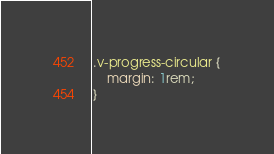Convert code to text. <code><loc_0><loc_0><loc_500><loc_500><_CSS_>.v-progress-circular {
    margin: 1rem;
}</code> 